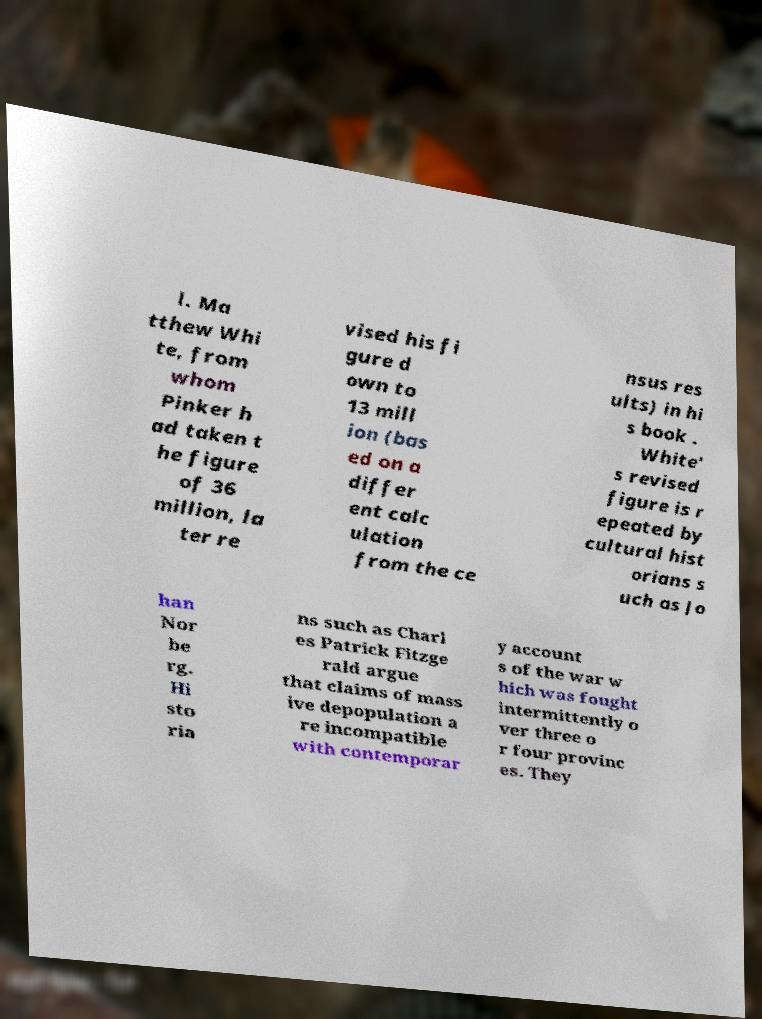There's text embedded in this image that I need extracted. Can you transcribe it verbatim? l. Ma tthew Whi te, from whom Pinker h ad taken t he figure of 36 million, la ter re vised his fi gure d own to 13 mill ion (bas ed on a differ ent calc ulation from the ce nsus res ults) in hi s book . White' s revised figure is r epeated by cultural hist orians s uch as Jo han Nor be rg. Hi sto ria ns such as Charl es Patrick Fitzge rald argue that claims of mass ive depopulation a re incompatible with contemporar y account s of the war w hich was fought intermittently o ver three o r four provinc es. They 